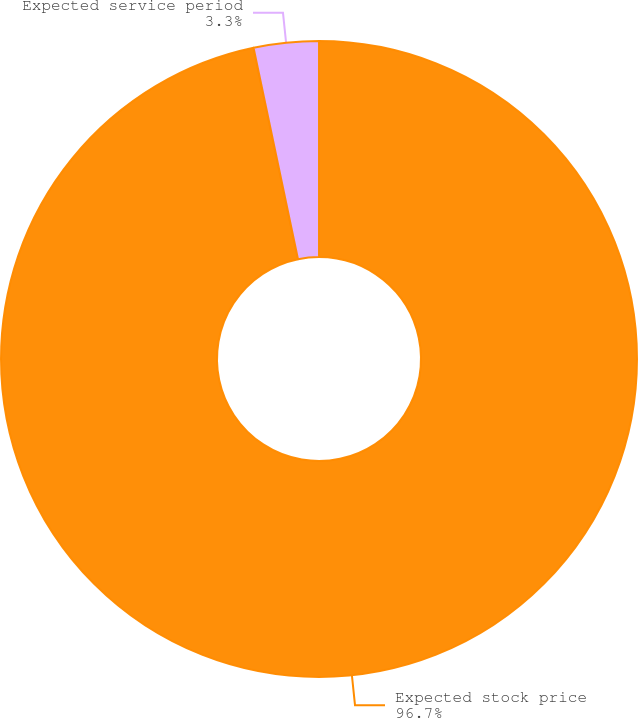Convert chart to OTSL. <chart><loc_0><loc_0><loc_500><loc_500><pie_chart><fcel>Expected stock price<fcel>Expected service period<nl><fcel>96.7%<fcel>3.3%<nl></chart> 